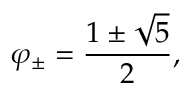<formula> <loc_0><loc_0><loc_500><loc_500>\varphi _ { \pm } = { \frac { 1 \pm { \sqrt { 5 } } } { 2 } } ,</formula> 